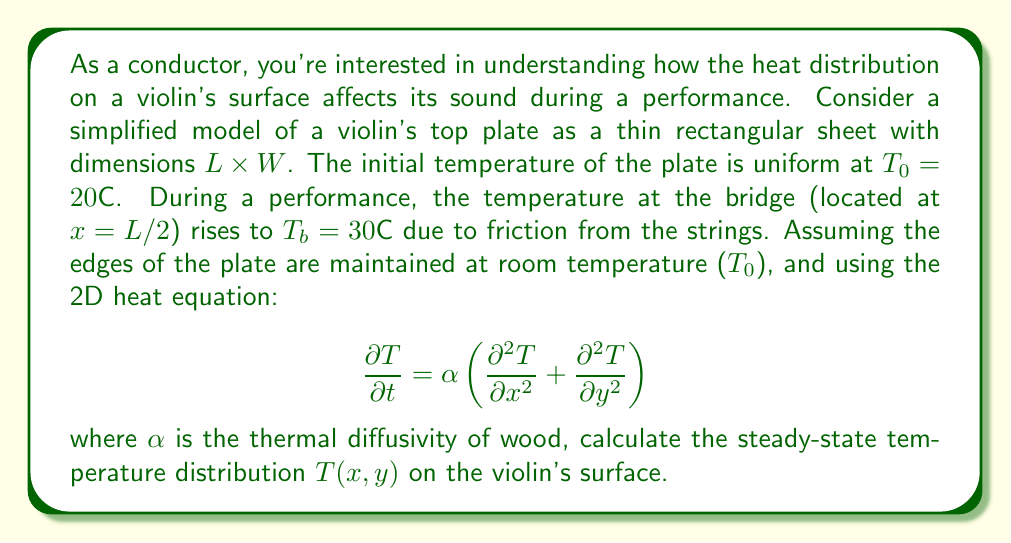Give your solution to this math problem. To solve this problem, we'll follow these steps:

1) For the steady-state solution, $\frac{\partial T}{\partial t} = 0$, so our equation becomes:

   $$\frac{\partial^2 T}{\partial x^2} + \frac{\partial^2 T}{\partial y^2} = 0$$

2) Given the symmetry of the problem, we can assume the temperature distribution is symmetric about the y-axis. We'll use separation of variables:

   $$T(x,y) = X(x)Y(y)$$

3) Substituting this into our equation:

   $$Y\frac{d^2X}{dx^2} + X\frac{d^2Y}{dy^2} = 0$$

4) Dividing by $XY$:

   $$\frac{1}{X}\frac{d^2X}{dx^2} = -\frac{1}{Y}\frac{d^2Y}{dy^2} = k^2$$

   where $k$ is a constant.

5) This gives us two ordinary differential equations:

   $$\frac{d^2X}{dx^2} + k^2X = 0$$
   $$\frac{d^2Y}{dy^2} - k^2Y = 0$$

6) The general solutions are:

   $$X(x) = A\cos(kx) + B\sin(kx)$$
   $$Y(y) = C\cosh(ky) + D\sinh(ky)$$

7) Applying the boundary conditions:
   - At $x = 0$ and $x = L$, $T = T_0$
   - At $y = 0$ and $y = W$, $T = T_0$
   - At $x = L/2$, $T = T_b$

8) These conditions lead to:

   $$T(x,y) = T_0 + (T_b - T_0)\frac{\cosh(n\pi y/L) - \cosh(n\pi(W-y)/L)}{\cosh(n\pi W/2L)}\cos(n\pi x/L)$$

   where $n$ is an odd integer.

9) The complete solution is the sum of all odd $n$ terms:

   $$T(x,y) = T_0 + (T_b - T_0)\sum_{n\text{ odd}}\frac{\cosh(n\pi y/L) - \cosh(n\pi(W-y)/L)}{\cosh(n\pi W/2L)}\cos(n\pi x/L)$$

This infinite series converges rapidly, so the first few terms provide a good approximation.
Answer: $T(x,y) = T_0 + (T_b - T_0)\sum_{n\text{ odd}}\frac{\cosh(n\pi y/L) - \cosh(n\pi(W-y)/L)}{\cosh(n\pi W/2L)}\cos(n\pi x/L)$ 